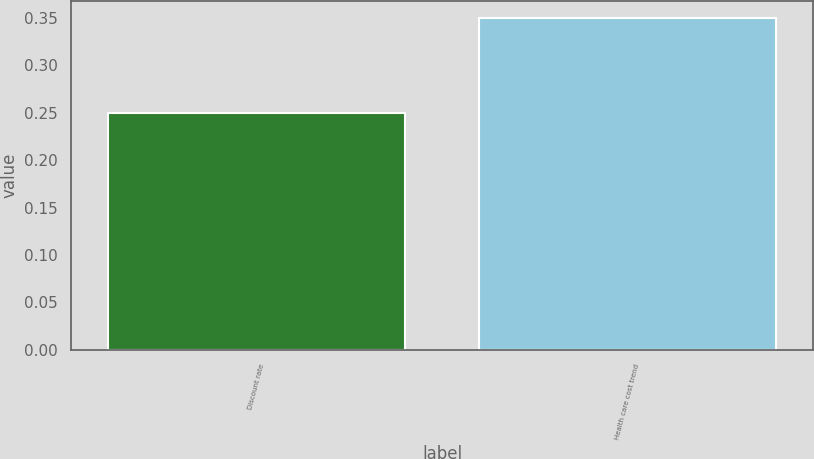Convert chart to OTSL. <chart><loc_0><loc_0><loc_500><loc_500><bar_chart><fcel>Discount rate<fcel>Health care cost trend<nl><fcel>0.25<fcel>0.35<nl></chart> 